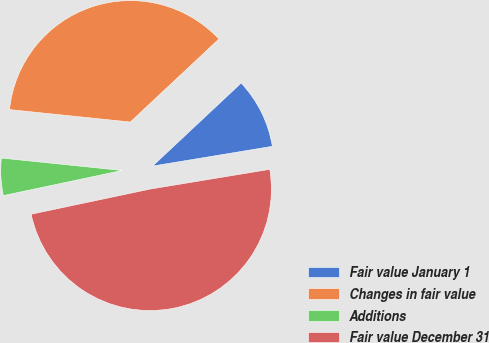Convert chart to OTSL. <chart><loc_0><loc_0><loc_500><loc_500><pie_chart><fcel>Fair value January 1<fcel>Changes in fair value<fcel>Additions<fcel>Fair value December 31<nl><fcel>9.38%<fcel>36.38%<fcel>4.95%<fcel>49.28%<nl></chart> 